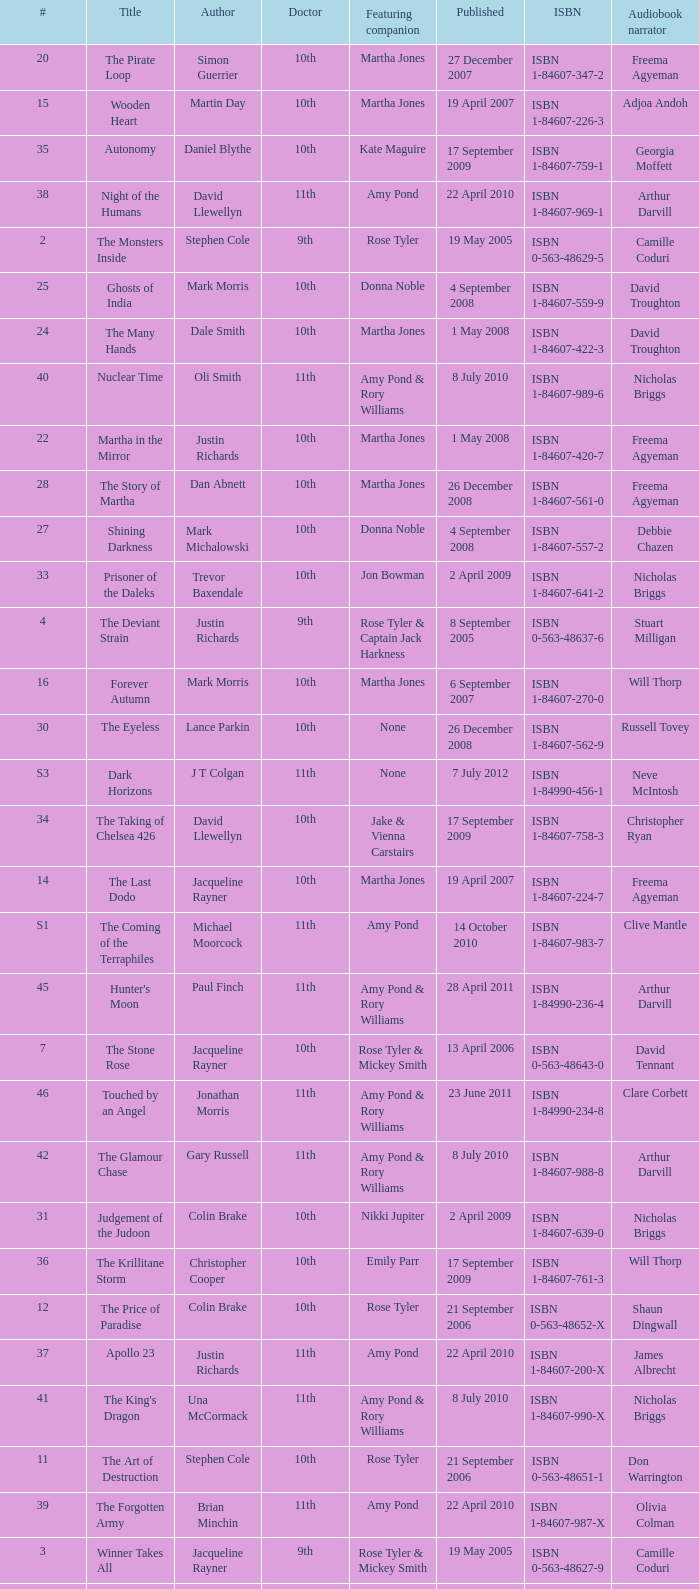What is the title of book number 7? The Stone Rose. 